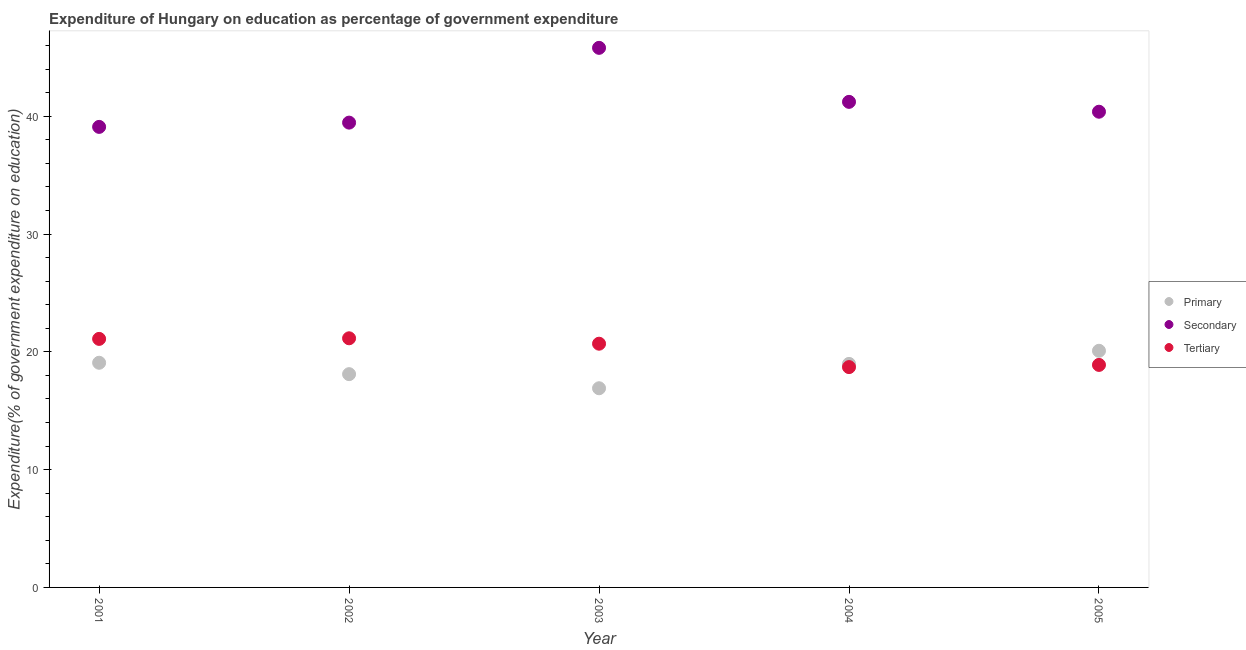How many different coloured dotlines are there?
Provide a succinct answer. 3. Is the number of dotlines equal to the number of legend labels?
Give a very brief answer. Yes. What is the expenditure on secondary education in 2004?
Your answer should be compact. 41.22. Across all years, what is the maximum expenditure on tertiary education?
Your response must be concise. 21.15. Across all years, what is the minimum expenditure on tertiary education?
Ensure brevity in your answer.  18.71. What is the total expenditure on secondary education in the graph?
Offer a terse response. 205.97. What is the difference between the expenditure on tertiary education in 2002 and that in 2004?
Your answer should be compact. 2.45. What is the difference between the expenditure on tertiary education in 2002 and the expenditure on secondary education in 2004?
Your response must be concise. -20.07. What is the average expenditure on primary education per year?
Your answer should be very brief. 18.63. In the year 2002, what is the difference between the expenditure on secondary education and expenditure on tertiary education?
Provide a succinct answer. 18.31. What is the ratio of the expenditure on secondary education in 2002 to that in 2004?
Ensure brevity in your answer.  0.96. Is the expenditure on secondary education in 2003 less than that in 2004?
Offer a very short reply. No. What is the difference between the highest and the second highest expenditure on secondary education?
Keep it short and to the point. 4.59. What is the difference between the highest and the lowest expenditure on primary education?
Provide a short and direct response. 3.18. Is the expenditure on primary education strictly greater than the expenditure on tertiary education over the years?
Provide a succinct answer. No. How many dotlines are there?
Offer a very short reply. 3. How many years are there in the graph?
Your answer should be very brief. 5. What is the difference between two consecutive major ticks on the Y-axis?
Provide a succinct answer. 10. Are the values on the major ticks of Y-axis written in scientific E-notation?
Provide a short and direct response. No. Does the graph contain grids?
Make the answer very short. No. How many legend labels are there?
Provide a short and direct response. 3. What is the title of the graph?
Keep it short and to the point. Expenditure of Hungary on education as percentage of government expenditure. What is the label or title of the X-axis?
Your answer should be very brief. Year. What is the label or title of the Y-axis?
Your response must be concise. Expenditure(% of government expenditure on education). What is the Expenditure(% of government expenditure on education) of Primary in 2001?
Ensure brevity in your answer.  19.07. What is the Expenditure(% of government expenditure on education) in Secondary in 2001?
Give a very brief answer. 39.1. What is the Expenditure(% of government expenditure on education) of Tertiary in 2001?
Give a very brief answer. 21.1. What is the Expenditure(% of government expenditure on education) in Primary in 2002?
Provide a succinct answer. 18.11. What is the Expenditure(% of government expenditure on education) in Secondary in 2002?
Provide a succinct answer. 39.46. What is the Expenditure(% of government expenditure on education) in Tertiary in 2002?
Provide a succinct answer. 21.15. What is the Expenditure(% of government expenditure on education) of Primary in 2003?
Ensure brevity in your answer.  16.91. What is the Expenditure(% of government expenditure on education) of Secondary in 2003?
Give a very brief answer. 45.81. What is the Expenditure(% of government expenditure on education) of Tertiary in 2003?
Your response must be concise. 20.69. What is the Expenditure(% of government expenditure on education) of Primary in 2004?
Give a very brief answer. 18.98. What is the Expenditure(% of government expenditure on education) in Secondary in 2004?
Make the answer very short. 41.22. What is the Expenditure(% of government expenditure on education) in Tertiary in 2004?
Offer a very short reply. 18.71. What is the Expenditure(% of government expenditure on education) of Primary in 2005?
Provide a succinct answer. 20.09. What is the Expenditure(% of government expenditure on education) of Secondary in 2005?
Your answer should be very brief. 40.39. What is the Expenditure(% of government expenditure on education) of Tertiary in 2005?
Offer a very short reply. 18.89. Across all years, what is the maximum Expenditure(% of government expenditure on education) in Primary?
Make the answer very short. 20.09. Across all years, what is the maximum Expenditure(% of government expenditure on education) of Secondary?
Ensure brevity in your answer.  45.81. Across all years, what is the maximum Expenditure(% of government expenditure on education) of Tertiary?
Make the answer very short. 21.15. Across all years, what is the minimum Expenditure(% of government expenditure on education) in Primary?
Give a very brief answer. 16.91. Across all years, what is the minimum Expenditure(% of government expenditure on education) in Secondary?
Make the answer very short. 39.1. Across all years, what is the minimum Expenditure(% of government expenditure on education) in Tertiary?
Give a very brief answer. 18.71. What is the total Expenditure(% of government expenditure on education) in Primary in the graph?
Keep it short and to the point. 93.15. What is the total Expenditure(% of government expenditure on education) of Secondary in the graph?
Provide a succinct answer. 205.97. What is the total Expenditure(% of government expenditure on education) in Tertiary in the graph?
Make the answer very short. 100.54. What is the difference between the Expenditure(% of government expenditure on education) of Primary in 2001 and that in 2002?
Offer a very short reply. 0.97. What is the difference between the Expenditure(% of government expenditure on education) of Secondary in 2001 and that in 2002?
Your response must be concise. -0.36. What is the difference between the Expenditure(% of government expenditure on education) in Tertiary in 2001 and that in 2002?
Offer a terse response. -0.05. What is the difference between the Expenditure(% of government expenditure on education) of Primary in 2001 and that in 2003?
Offer a terse response. 2.16. What is the difference between the Expenditure(% of government expenditure on education) of Secondary in 2001 and that in 2003?
Your response must be concise. -6.71. What is the difference between the Expenditure(% of government expenditure on education) in Tertiary in 2001 and that in 2003?
Make the answer very short. 0.41. What is the difference between the Expenditure(% of government expenditure on education) of Primary in 2001 and that in 2004?
Your response must be concise. 0.1. What is the difference between the Expenditure(% of government expenditure on education) of Secondary in 2001 and that in 2004?
Offer a very short reply. -2.12. What is the difference between the Expenditure(% of government expenditure on education) of Tertiary in 2001 and that in 2004?
Your answer should be very brief. 2.39. What is the difference between the Expenditure(% of government expenditure on education) of Primary in 2001 and that in 2005?
Keep it short and to the point. -1.02. What is the difference between the Expenditure(% of government expenditure on education) of Secondary in 2001 and that in 2005?
Offer a terse response. -1.29. What is the difference between the Expenditure(% of government expenditure on education) of Tertiary in 2001 and that in 2005?
Provide a short and direct response. 2.21. What is the difference between the Expenditure(% of government expenditure on education) of Primary in 2002 and that in 2003?
Make the answer very short. 1.2. What is the difference between the Expenditure(% of government expenditure on education) of Secondary in 2002 and that in 2003?
Give a very brief answer. -6.35. What is the difference between the Expenditure(% of government expenditure on education) of Tertiary in 2002 and that in 2003?
Offer a very short reply. 0.46. What is the difference between the Expenditure(% of government expenditure on education) of Primary in 2002 and that in 2004?
Your answer should be very brief. -0.87. What is the difference between the Expenditure(% of government expenditure on education) of Secondary in 2002 and that in 2004?
Provide a succinct answer. -1.76. What is the difference between the Expenditure(% of government expenditure on education) of Tertiary in 2002 and that in 2004?
Provide a short and direct response. 2.45. What is the difference between the Expenditure(% of government expenditure on education) of Primary in 2002 and that in 2005?
Your answer should be compact. -1.98. What is the difference between the Expenditure(% of government expenditure on education) of Secondary in 2002 and that in 2005?
Give a very brief answer. -0.93. What is the difference between the Expenditure(% of government expenditure on education) of Tertiary in 2002 and that in 2005?
Your answer should be compact. 2.26. What is the difference between the Expenditure(% of government expenditure on education) in Primary in 2003 and that in 2004?
Your answer should be very brief. -2.07. What is the difference between the Expenditure(% of government expenditure on education) of Secondary in 2003 and that in 2004?
Ensure brevity in your answer.  4.59. What is the difference between the Expenditure(% of government expenditure on education) in Tertiary in 2003 and that in 2004?
Offer a terse response. 1.99. What is the difference between the Expenditure(% of government expenditure on education) in Primary in 2003 and that in 2005?
Keep it short and to the point. -3.18. What is the difference between the Expenditure(% of government expenditure on education) in Secondary in 2003 and that in 2005?
Your answer should be very brief. 5.42. What is the difference between the Expenditure(% of government expenditure on education) in Tertiary in 2003 and that in 2005?
Make the answer very short. 1.8. What is the difference between the Expenditure(% of government expenditure on education) of Primary in 2004 and that in 2005?
Provide a succinct answer. -1.11. What is the difference between the Expenditure(% of government expenditure on education) of Secondary in 2004 and that in 2005?
Give a very brief answer. 0.84. What is the difference between the Expenditure(% of government expenditure on education) of Tertiary in 2004 and that in 2005?
Offer a very short reply. -0.19. What is the difference between the Expenditure(% of government expenditure on education) of Primary in 2001 and the Expenditure(% of government expenditure on education) of Secondary in 2002?
Provide a succinct answer. -20.39. What is the difference between the Expenditure(% of government expenditure on education) in Primary in 2001 and the Expenditure(% of government expenditure on education) in Tertiary in 2002?
Provide a succinct answer. -2.08. What is the difference between the Expenditure(% of government expenditure on education) in Secondary in 2001 and the Expenditure(% of government expenditure on education) in Tertiary in 2002?
Offer a terse response. 17.95. What is the difference between the Expenditure(% of government expenditure on education) in Primary in 2001 and the Expenditure(% of government expenditure on education) in Secondary in 2003?
Make the answer very short. -26.74. What is the difference between the Expenditure(% of government expenditure on education) in Primary in 2001 and the Expenditure(% of government expenditure on education) in Tertiary in 2003?
Give a very brief answer. -1.62. What is the difference between the Expenditure(% of government expenditure on education) in Secondary in 2001 and the Expenditure(% of government expenditure on education) in Tertiary in 2003?
Make the answer very short. 18.41. What is the difference between the Expenditure(% of government expenditure on education) of Primary in 2001 and the Expenditure(% of government expenditure on education) of Secondary in 2004?
Give a very brief answer. -22.15. What is the difference between the Expenditure(% of government expenditure on education) in Primary in 2001 and the Expenditure(% of government expenditure on education) in Tertiary in 2004?
Ensure brevity in your answer.  0.37. What is the difference between the Expenditure(% of government expenditure on education) of Secondary in 2001 and the Expenditure(% of government expenditure on education) of Tertiary in 2004?
Provide a succinct answer. 20.39. What is the difference between the Expenditure(% of government expenditure on education) in Primary in 2001 and the Expenditure(% of government expenditure on education) in Secondary in 2005?
Provide a succinct answer. -21.31. What is the difference between the Expenditure(% of government expenditure on education) in Primary in 2001 and the Expenditure(% of government expenditure on education) in Tertiary in 2005?
Give a very brief answer. 0.18. What is the difference between the Expenditure(% of government expenditure on education) of Secondary in 2001 and the Expenditure(% of government expenditure on education) of Tertiary in 2005?
Your answer should be very brief. 20.21. What is the difference between the Expenditure(% of government expenditure on education) of Primary in 2002 and the Expenditure(% of government expenditure on education) of Secondary in 2003?
Your answer should be compact. -27.7. What is the difference between the Expenditure(% of government expenditure on education) in Primary in 2002 and the Expenditure(% of government expenditure on education) in Tertiary in 2003?
Make the answer very short. -2.58. What is the difference between the Expenditure(% of government expenditure on education) in Secondary in 2002 and the Expenditure(% of government expenditure on education) in Tertiary in 2003?
Offer a terse response. 18.77. What is the difference between the Expenditure(% of government expenditure on education) in Primary in 2002 and the Expenditure(% of government expenditure on education) in Secondary in 2004?
Offer a very short reply. -23.12. What is the difference between the Expenditure(% of government expenditure on education) in Primary in 2002 and the Expenditure(% of government expenditure on education) in Tertiary in 2004?
Give a very brief answer. -0.6. What is the difference between the Expenditure(% of government expenditure on education) in Secondary in 2002 and the Expenditure(% of government expenditure on education) in Tertiary in 2004?
Offer a very short reply. 20.75. What is the difference between the Expenditure(% of government expenditure on education) in Primary in 2002 and the Expenditure(% of government expenditure on education) in Secondary in 2005?
Your answer should be very brief. -22.28. What is the difference between the Expenditure(% of government expenditure on education) in Primary in 2002 and the Expenditure(% of government expenditure on education) in Tertiary in 2005?
Your answer should be very brief. -0.78. What is the difference between the Expenditure(% of government expenditure on education) in Secondary in 2002 and the Expenditure(% of government expenditure on education) in Tertiary in 2005?
Offer a very short reply. 20.57. What is the difference between the Expenditure(% of government expenditure on education) in Primary in 2003 and the Expenditure(% of government expenditure on education) in Secondary in 2004?
Make the answer very short. -24.31. What is the difference between the Expenditure(% of government expenditure on education) of Primary in 2003 and the Expenditure(% of government expenditure on education) of Tertiary in 2004?
Provide a succinct answer. -1.8. What is the difference between the Expenditure(% of government expenditure on education) in Secondary in 2003 and the Expenditure(% of government expenditure on education) in Tertiary in 2004?
Your response must be concise. 27.1. What is the difference between the Expenditure(% of government expenditure on education) of Primary in 2003 and the Expenditure(% of government expenditure on education) of Secondary in 2005?
Give a very brief answer. -23.48. What is the difference between the Expenditure(% of government expenditure on education) of Primary in 2003 and the Expenditure(% of government expenditure on education) of Tertiary in 2005?
Give a very brief answer. -1.98. What is the difference between the Expenditure(% of government expenditure on education) of Secondary in 2003 and the Expenditure(% of government expenditure on education) of Tertiary in 2005?
Your answer should be compact. 26.92. What is the difference between the Expenditure(% of government expenditure on education) in Primary in 2004 and the Expenditure(% of government expenditure on education) in Secondary in 2005?
Give a very brief answer. -21.41. What is the difference between the Expenditure(% of government expenditure on education) in Primary in 2004 and the Expenditure(% of government expenditure on education) in Tertiary in 2005?
Provide a short and direct response. 0.09. What is the difference between the Expenditure(% of government expenditure on education) of Secondary in 2004 and the Expenditure(% of government expenditure on education) of Tertiary in 2005?
Your response must be concise. 22.33. What is the average Expenditure(% of government expenditure on education) in Primary per year?
Your response must be concise. 18.63. What is the average Expenditure(% of government expenditure on education) of Secondary per year?
Offer a very short reply. 41.2. What is the average Expenditure(% of government expenditure on education) of Tertiary per year?
Keep it short and to the point. 20.11. In the year 2001, what is the difference between the Expenditure(% of government expenditure on education) in Primary and Expenditure(% of government expenditure on education) in Secondary?
Your response must be concise. -20.02. In the year 2001, what is the difference between the Expenditure(% of government expenditure on education) in Primary and Expenditure(% of government expenditure on education) in Tertiary?
Your response must be concise. -2.03. In the year 2001, what is the difference between the Expenditure(% of government expenditure on education) of Secondary and Expenditure(% of government expenditure on education) of Tertiary?
Your answer should be very brief. 18. In the year 2002, what is the difference between the Expenditure(% of government expenditure on education) of Primary and Expenditure(% of government expenditure on education) of Secondary?
Ensure brevity in your answer.  -21.35. In the year 2002, what is the difference between the Expenditure(% of government expenditure on education) in Primary and Expenditure(% of government expenditure on education) in Tertiary?
Provide a short and direct response. -3.04. In the year 2002, what is the difference between the Expenditure(% of government expenditure on education) in Secondary and Expenditure(% of government expenditure on education) in Tertiary?
Make the answer very short. 18.31. In the year 2003, what is the difference between the Expenditure(% of government expenditure on education) in Primary and Expenditure(% of government expenditure on education) in Secondary?
Your answer should be compact. -28.9. In the year 2003, what is the difference between the Expenditure(% of government expenditure on education) of Primary and Expenditure(% of government expenditure on education) of Tertiary?
Offer a very short reply. -3.78. In the year 2003, what is the difference between the Expenditure(% of government expenditure on education) in Secondary and Expenditure(% of government expenditure on education) in Tertiary?
Offer a terse response. 25.12. In the year 2004, what is the difference between the Expenditure(% of government expenditure on education) of Primary and Expenditure(% of government expenditure on education) of Secondary?
Give a very brief answer. -22.25. In the year 2004, what is the difference between the Expenditure(% of government expenditure on education) in Primary and Expenditure(% of government expenditure on education) in Tertiary?
Your answer should be compact. 0.27. In the year 2004, what is the difference between the Expenditure(% of government expenditure on education) in Secondary and Expenditure(% of government expenditure on education) in Tertiary?
Provide a short and direct response. 22.52. In the year 2005, what is the difference between the Expenditure(% of government expenditure on education) of Primary and Expenditure(% of government expenditure on education) of Secondary?
Give a very brief answer. -20.3. In the year 2005, what is the difference between the Expenditure(% of government expenditure on education) in Primary and Expenditure(% of government expenditure on education) in Tertiary?
Your answer should be very brief. 1.2. In the year 2005, what is the difference between the Expenditure(% of government expenditure on education) of Secondary and Expenditure(% of government expenditure on education) of Tertiary?
Ensure brevity in your answer.  21.49. What is the ratio of the Expenditure(% of government expenditure on education) in Primary in 2001 to that in 2002?
Your answer should be compact. 1.05. What is the ratio of the Expenditure(% of government expenditure on education) of Primary in 2001 to that in 2003?
Make the answer very short. 1.13. What is the ratio of the Expenditure(% of government expenditure on education) of Secondary in 2001 to that in 2003?
Your answer should be very brief. 0.85. What is the ratio of the Expenditure(% of government expenditure on education) in Tertiary in 2001 to that in 2003?
Your response must be concise. 1.02. What is the ratio of the Expenditure(% of government expenditure on education) in Primary in 2001 to that in 2004?
Ensure brevity in your answer.  1.01. What is the ratio of the Expenditure(% of government expenditure on education) of Secondary in 2001 to that in 2004?
Provide a short and direct response. 0.95. What is the ratio of the Expenditure(% of government expenditure on education) of Tertiary in 2001 to that in 2004?
Your answer should be compact. 1.13. What is the ratio of the Expenditure(% of government expenditure on education) of Primary in 2001 to that in 2005?
Make the answer very short. 0.95. What is the ratio of the Expenditure(% of government expenditure on education) in Secondary in 2001 to that in 2005?
Make the answer very short. 0.97. What is the ratio of the Expenditure(% of government expenditure on education) of Tertiary in 2001 to that in 2005?
Your answer should be compact. 1.12. What is the ratio of the Expenditure(% of government expenditure on education) in Primary in 2002 to that in 2003?
Provide a succinct answer. 1.07. What is the ratio of the Expenditure(% of government expenditure on education) of Secondary in 2002 to that in 2003?
Your answer should be very brief. 0.86. What is the ratio of the Expenditure(% of government expenditure on education) of Tertiary in 2002 to that in 2003?
Provide a short and direct response. 1.02. What is the ratio of the Expenditure(% of government expenditure on education) in Primary in 2002 to that in 2004?
Ensure brevity in your answer.  0.95. What is the ratio of the Expenditure(% of government expenditure on education) in Secondary in 2002 to that in 2004?
Ensure brevity in your answer.  0.96. What is the ratio of the Expenditure(% of government expenditure on education) of Tertiary in 2002 to that in 2004?
Your response must be concise. 1.13. What is the ratio of the Expenditure(% of government expenditure on education) of Primary in 2002 to that in 2005?
Provide a succinct answer. 0.9. What is the ratio of the Expenditure(% of government expenditure on education) of Secondary in 2002 to that in 2005?
Offer a terse response. 0.98. What is the ratio of the Expenditure(% of government expenditure on education) in Tertiary in 2002 to that in 2005?
Keep it short and to the point. 1.12. What is the ratio of the Expenditure(% of government expenditure on education) in Primary in 2003 to that in 2004?
Offer a terse response. 0.89. What is the ratio of the Expenditure(% of government expenditure on education) in Secondary in 2003 to that in 2004?
Give a very brief answer. 1.11. What is the ratio of the Expenditure(% of government expenditure on education) of Tertiary in 2003 to that in 2004?
Your response must be concise. 1.11. What is the ratio of the Expenditure(% of government expenditure on education) of Primary in 2003 to that in 2005?
Provide a short and direct response. 0.84. What is the ratio of the Expenditure(% of government expenditure on education) in Secondary in 2003 to that in 2005?
Provide a short and direct response. 1.13. What is the ratio of the Expenditure(% of government expenditure on education) in Tertiary in 2003 to that in 2005?
Make the answer very short. 1.1. What is the ratio of the Expenditure(% of government expenditure on education) of Primary in 2004 to that in 2005?
Make the answer very short. 0.94. What is the ratio of the Expenditure(% of government expenditure on education) of Secondary in 2004 to that in 2005?
Your answer should be compact. 1.02. What is the ratio of the Expenditure(% of government expenditure on education) of Tertiary in 2004 to that in 2005?
Provide a short and direct response. 0.99. What is the difference between the highest and the second highest Expenditure(% of government expenditure on education) of Primary?
Make the answer very short. 1.02. What is the difference between the highest and the second highest Expenditure(% of government expenditure on education) in Secondary?
Provide a succinct answer. 4.59. What is the difference between the highest and the second highest Expenditure(% of government expenditure on education) of Tertiary?
Offer a terse response. 0.05. What is the difference between the highest and the lowest Expenditure(% of government expenditure on education) in Primary?
Your answer should be very brief. 3.18. What is the difference between the highest and the lowest Expenditure(% of government expenditure on education) of Secondary?
Your answer should be compact. 6.71. What is the difference between the highest and the lowest Expenditure(% of government expenditure on education) of Tertiary?
Your answer should be compact. 2.45. 